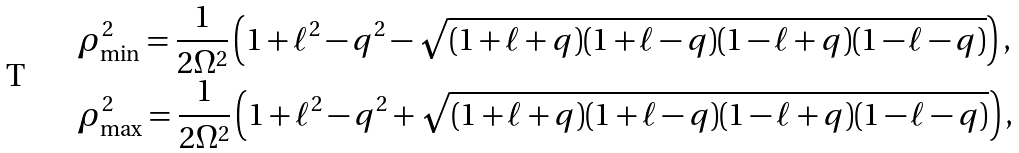<formula> <loc_0><loc_0><loc_500><loc_500>& \rho _ { \min } ^ { 2 } = \frac { 1 } { 2 \Omega ^ { 2 } } \left ( 1 + \ell ^ { 2 } - q ^ { 2 } - \sqrt { ( 1 + \ell + q ) ( 1 + \ell - q ) ( 1 - \ell + q ) ( 1 - \ell - q ) } \right ) , \\ & \rho _ { \max } ^ { 2 } = \frac { 1 } { 2 \Omega ^ { 2 } } \left ( 1 + \ell ^ { 2 } - q ^ { 2 } + \sqrt { ( 1 + \ell + q ) ( 1 + \ell - q ) ( 1 - \ell + q ) ( 1 - \ell - q ) } \right ) ,</formula> 